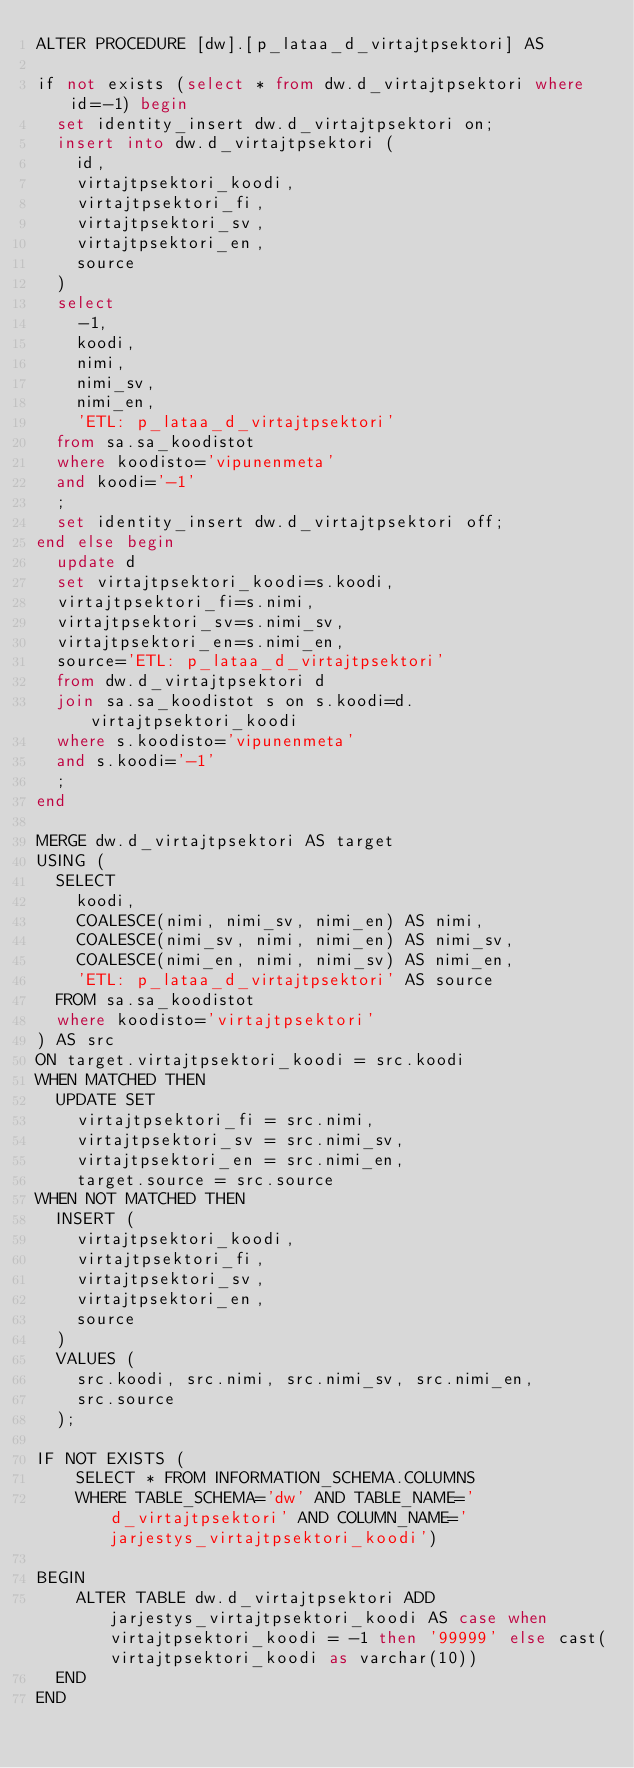Convert code to text. <code><loc_0><loc_0><loc_500><loc_500><_SQL_>ALTER PROCEDURE [dw].[p_lataa_d_virtajtpsektori] AS

if not exists (select * from dw.d_virtajtpsektori where id=-1) begin
  set identity_insert dw.d_virtajtpsektori on;
  insert into dw.d_virtajtpsektori (
    id,
    virtajtpsektori_koodi,
    virtajtpsektori_fi,
    virtajtpsektori_sv,
    virtajtpsektori_en,
    source
  )
  select
    -1,
    koodi,
    nimi,
    nimi_sv,
    nimi_en,
    'ETL: p_lataa_d_virtajtpsektori'
  from sa.sa_koodistot
  where koodisto='vipunenmeta'
  and koodi='-1'
  ;
  set identity_insert dw.d_virtajtpsektori off;
end else begin
  update d
  set virtajtpsektori_koodi=s.koodi,
  virtajtpsektori_fi=s.nimi,
  virtajtpsektori_sv=s.nimi_sv,
  virtajtpsektori_en=s.nimi_en,
  source='ETL: p_lataa_d_virtajtpsektori'
  from dw.d_virtajtpsektori d
  join sa.sa_koodistot s on s.koodi=d.virtajtpsektori_koodi
  where s.koodisto='vipunenmeta'
  and s.koodi='-1'
  ;
end

MERGE dw.d_virtajtpsektori AS target
USING (
  SELECT
    koodi,
    COALESCE(nimi, nimi_sv, nimi_en) AS nimi,
    COALESCE(nimi_sv, nimi, nimi_en) AS nimi_sv,
    COALESCE(nimi_en, nimi, nimi_sv) AS nimi_en,
    'ETL: p_lataa_d_virtajtpsektori' AS source
  FROM sa.sa_koodistot
  where koodisto='virtajtpsektori'
) AS src
ON target.virtajtpsektori_koodi = src.koodi
WHEN MATCHED THEN
  UPDATE SET
    virtajtpsektori_fi = src.nimi,
    virtajtpsektori_sv = src.nimi_sv,
    virtajtpsektori_en = src.nimi_en,
    target.source = src.source
WHEN NOT MATCHED THEN
  INSERT (
    virtajtpsektori_koodi,
    virtajtpsektori_fi,
    virtajtpsektori_sv,
    virtajtpsektori_en,
    source
  )
  VALUES (
    src.koodi, src.nimi, src.nimi_sv, src.nimi_en,
    src.source
  );

IF NOT EXISTS (
	SELECT * FROM INFORMATION_SCHEMA.COLUMNS
	WHERE TABLE_SCHEMA='dw' AND TABLE_NAME='d_virtajtpsektori' AND COLUMN_NAME='jarjestys_virtajtpsektori_koodi')

BEGIN
	ALTER TABLE dw.d_virtajtpsektori ADD jarjestys_virtajtpsektori_koodi AS case when virtajtpsektori_koodi = -1 then '99999' else cast(virtajtpsektori_koodi as varchar(10))
  END
END
</code> 